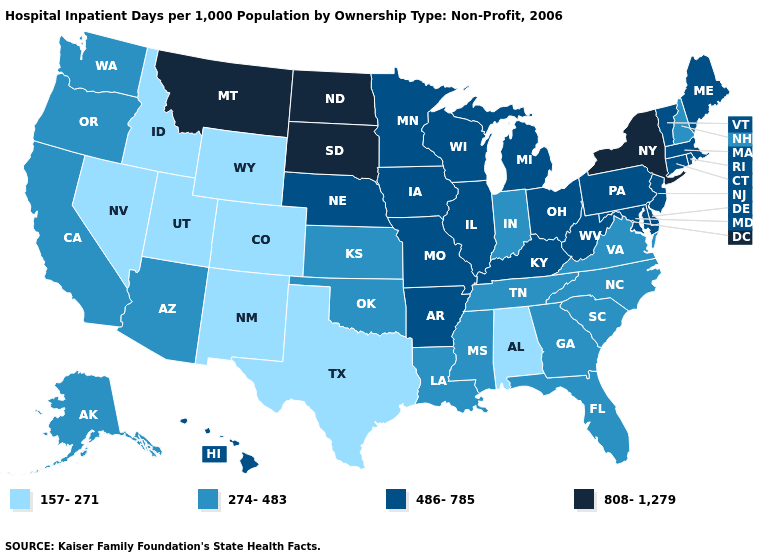Which states have the highest value in the USA?
Answer briefly. Montana, New York, North Dakota, South Dakota. Does North Dakota have the highest value in the MidWest?
Concise answer only. Yes. Among the states that border Washington , which have the lowest value?
Give a very brief answer. Idaho. Name the states that have a value in the range 157-271?
Quick response, please. Alabama, Colorado, Idaho, Nevada, New Mexico, Texas, Utah, Wyoming. What is the value of Illinois?
Quick response, please. 486-785. Among the states that border Missouri , which have the highest value?
Give a very brief answer. Arkansas, Illinois, Iowa, Kentucky, Nebraska. What is the value of Montana?
Concise answer only. 808-1,279. Does Illinois have the lowest value in the USA?
Write a very short answer. No. Name the states that have a value in the range 157-271?
Quick response, please. Alabama, Colorado, Idaho, Nevada, New Mexico, Texas, Utah, Wyoming. Among the states that border North Carolina , which have the lowest value?
Keep it brief. Georgia, South Carolina, Tennessee, Virginia. Is the legend a continuous bar?
Give a very brief answer. No. Name the states that have a value in the range 808-1,279?
Answer briefly. Montana, New York, North Dakota, South Dakota. Does Michigan have a lower value than New Jersey?
Concise answer only. No. 